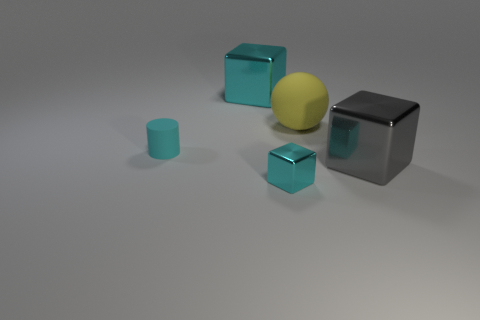Subtract all yellow balls. How many cyan cubes are left? 2 Subtract all tiny metallic cubes. How many cubes are left? 2 Add 3 big yellow metallic cubes. How many objects exist? 8 Subtract all red blocks. Subtract all green spheres. How many blocks are left? 3 Subtract all blocks. How many objects are left? 2 Add 1 tiny yellow cubes. How many tiny yellow cubes exist? 1 Subtract 1 cyan cubes. How many objects are left? 4 Subtract all cyan metallic blocks. Subtract all tiny red metal cubes. How many objects are left? 3 Add 5 yellow spheres. How many yellow spheres are left? 6 